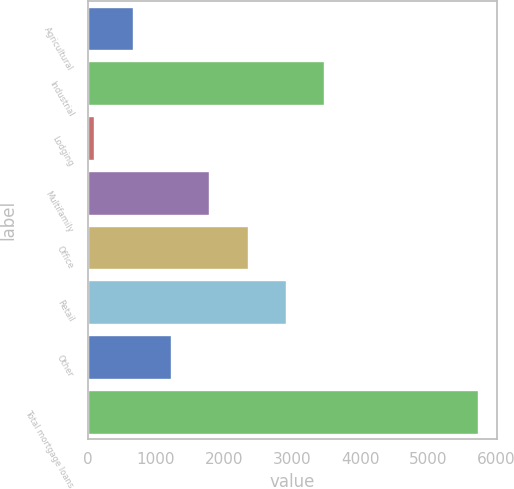Convert chart. <chart><loc_0><loc_0><loc_500><loc_500><bar_chart><fcel>Agricultural<fcel>Industrial<fcel>Lodging<fcel>Multifamily<fcel>Office<fcel>Retail<fcel>Other<fcel>Total mortgage loans<nl><fcel>656.5<fcel>3474<fcel>93<fcel>1783.5<fcel>2347<fcel>2910.5<fcel>1220<fcel>5728<nl></chart> 